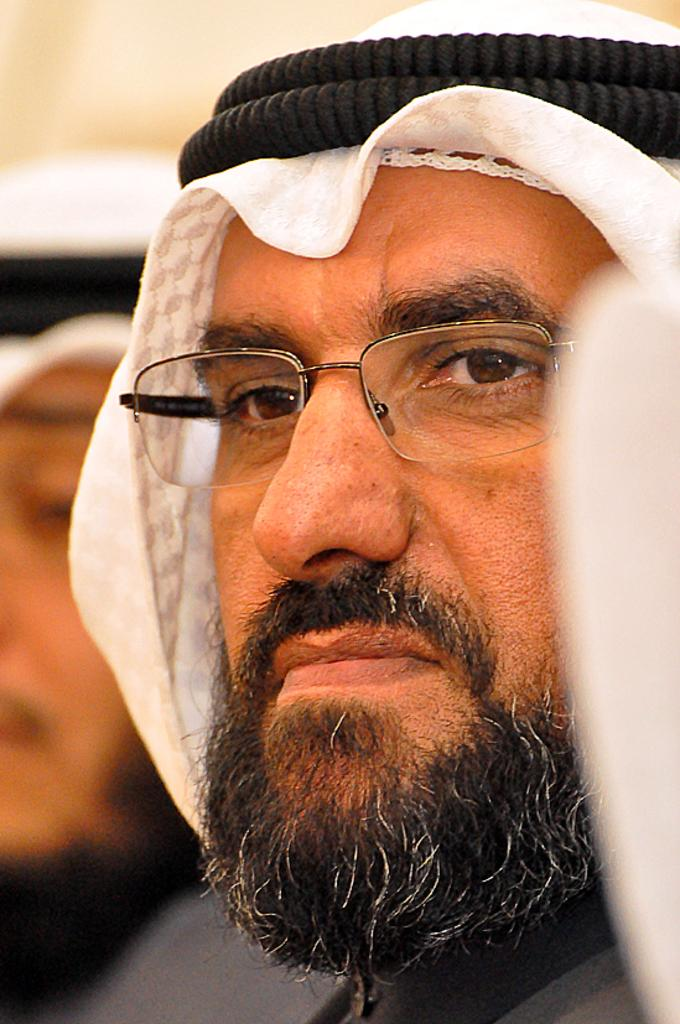How many people are in the image? There are two persons in the image. Can you describe one of the persons in the image? One of the persons is wearing spectacles. What can be seen in the background of the image? The background of the image appears to be a wall. What type of stem can be seen growing from the wall in the image? There is no stem growing from the wall in the image. Is there any blood visible on the persons in the image? There is no blood visible on the persons in the image. 